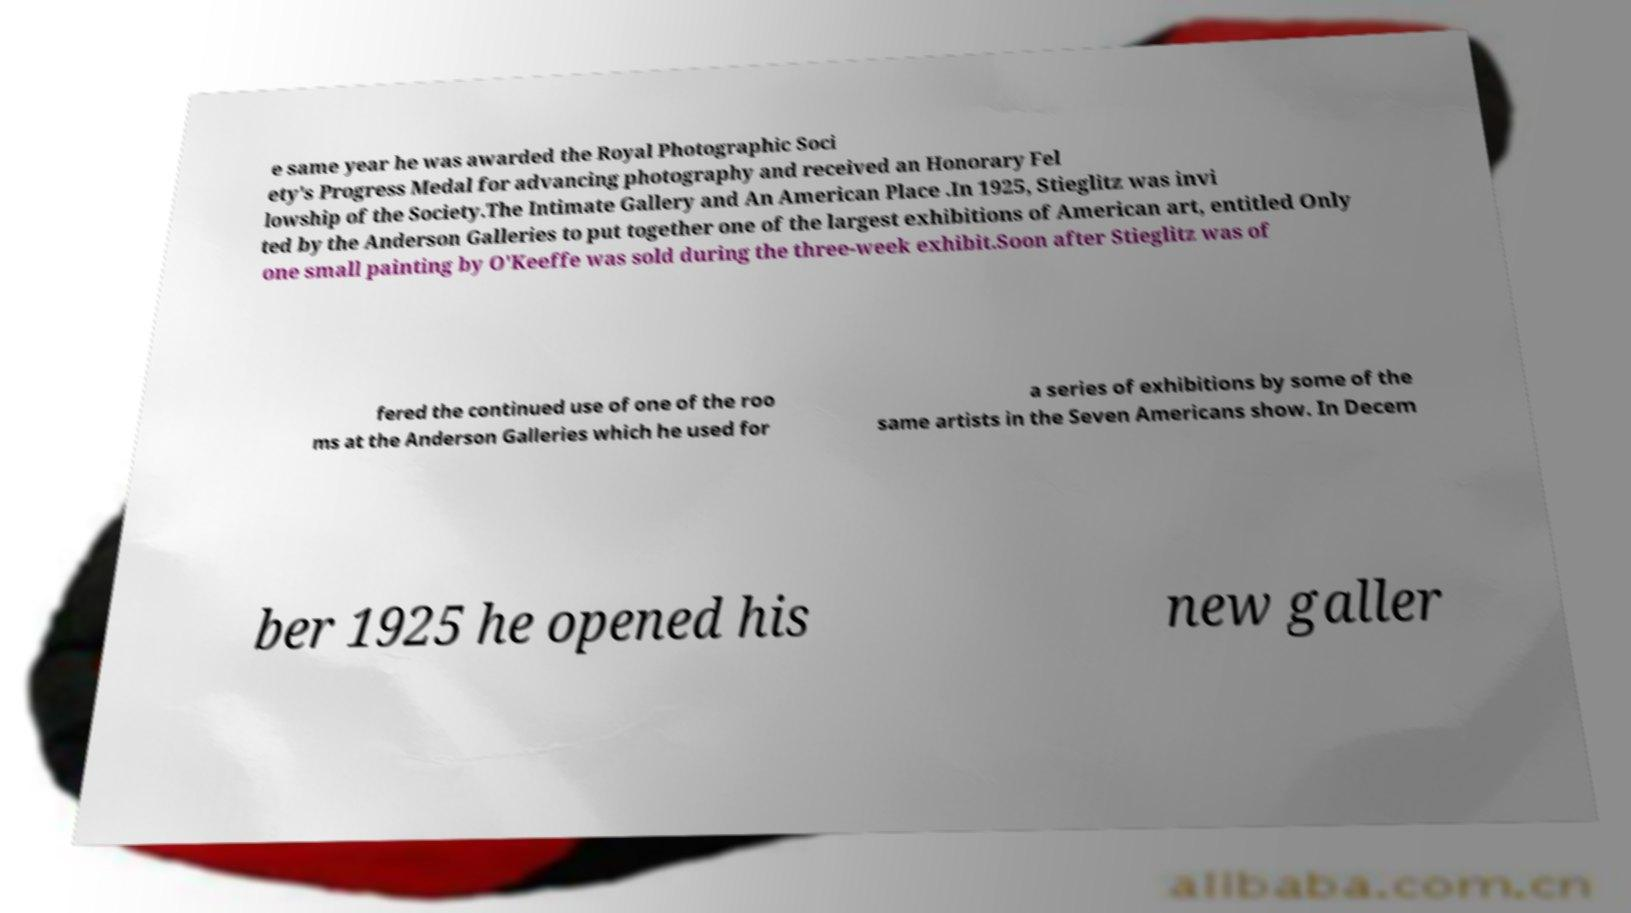Could you assist in decoding the text presented in this image and type it out clearly? e same year he was awarded the Royal Photographic Soci ety's Progress Medal for advancing photography and received an Honorary Fel lowship of the Society.The Intimate Gallery and An American Place .In 1925, Stieglitz was invi ted by the Anderson Galleries to put together one of the largest exhibitions of American art, entitled Only one small painting by O'Keeffe was sold during the three-week exhibit.Soon after Stieglitz was of fered the continued use of one of the roo ms at the Anderson Galleries which he used for a series of exhibitions by some of the same artists in the Seven Americans show. In Decem ber 1925 he opened his new galler 